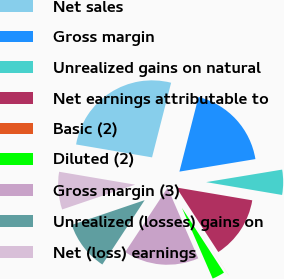Convert chart to OTSL. <chart><loc_0><loc_0><loc_500><loc_500><pie_chart><fcel>Net sales<fcel>Gross margin<fcel>Unrealized gains on natural<fcel>Net earnings attributable to<fcel>Basic (2)<fcel>Diluted (2)<fcel>Gross margin (3)<fcel>Unrealized (losses) gains on<fcel>Net (loss) earnings<nl><fcel>26.31%<fcel>18.42%<fcel>5.27%<fcel>13.16%<fcel>0.01%<fcel>2.64%<fcel>15.79%<fcel>10.53%<fcel>7.9%<nl></chart> 